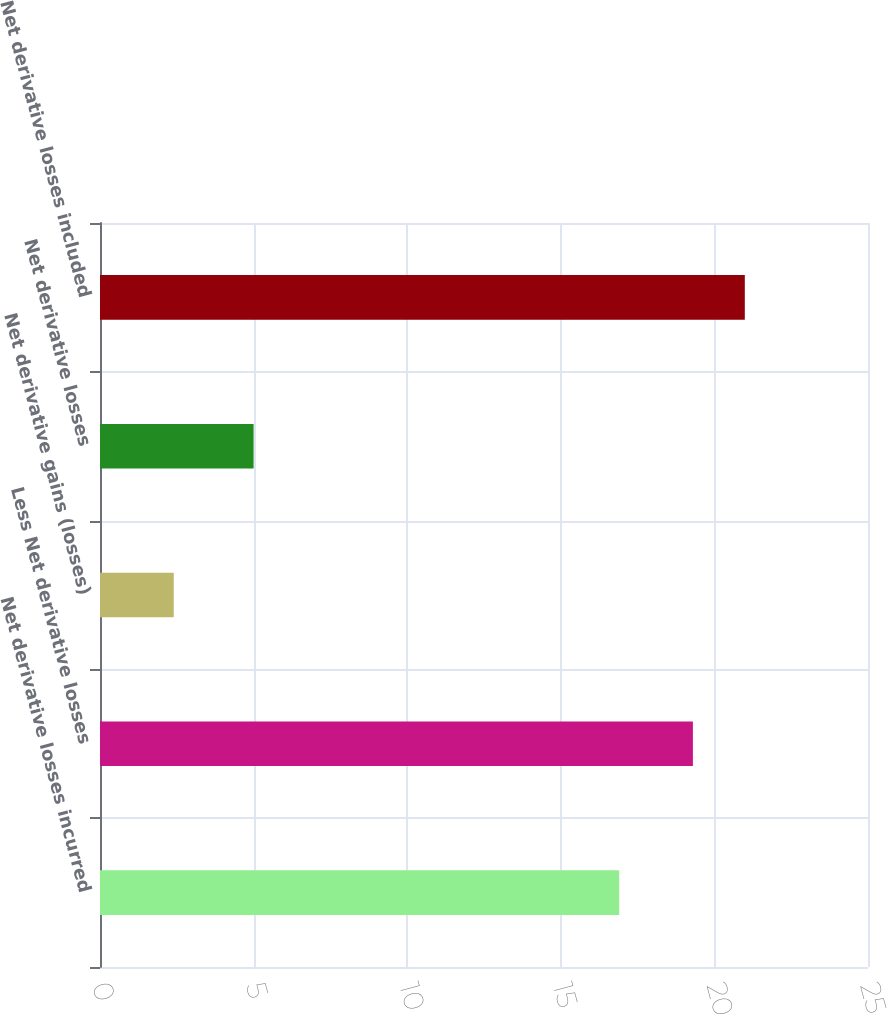Convert chart to OTSL. <chart><loc_0><loc_0><loc_500><loc_500><bar_chart><fcel>Net derivative losses incurred<fcel>Less Net derivative losses<fcel>Net derivative gains (losses)<fcel>Net derivative losses<fcel>Net derivative losses included<nl><fcel>16.9<fcel>19.3<fcel>2.4<fcel>5<fcel>20.99<nl></chart> 